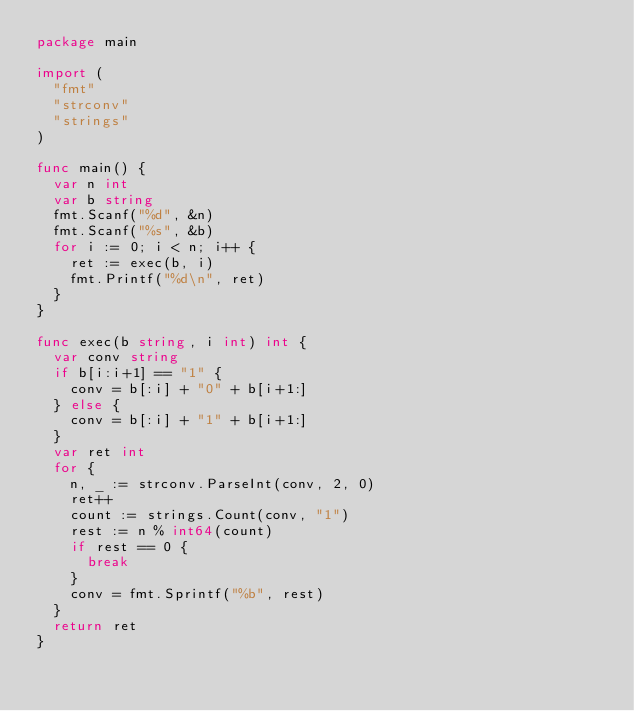Convert code to text. <code><loc_0><loc_0><loc_500><loc_500><_Go_>package main

import (
	"fmt"
	"strconv"
	"strings"
)

func main() {
	var n int
	var b string
	fmt.Scanf("%d", &n)
	fmt.Scanf("%s", &b)
	for i := 0; i < n; i++ {
		ret := exec(b, i)
		fmt.Printf("%d\n", ret)
	}
}

func exec(b string, i int) int {
	var conv string
	if b[i:i+1] == "1" {
		conv = b[:i] + "0" + b[i+1:]
	} else {
		conv = b[:i] + "1" + b[i+1:]
	}
	var ret int
	for {
		n, _ := strconv.ParseInt(conv, 2, 0)
		ret++
		count := strings.Count(conv, "1")
		rest := n % int64(count)
		if rest == 0 {
			break
		}
		conv = fmt.Sprintf("%b", rest)
	}
	return ret
}
</code> 